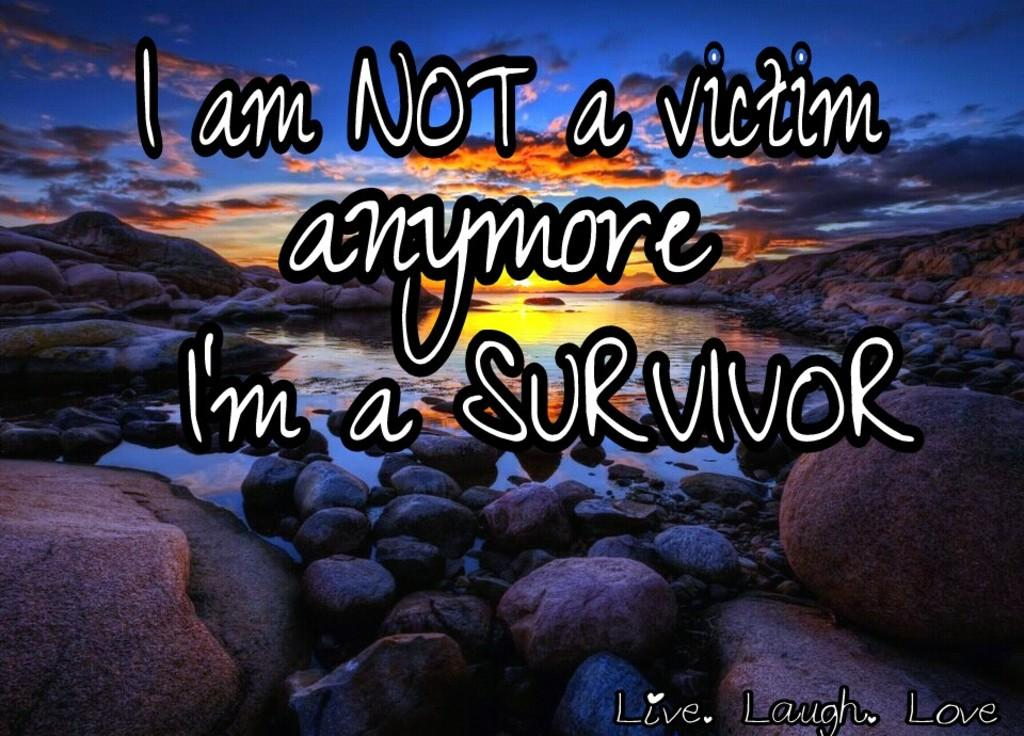<image>
Give a short and clear explanation of the subsequent image. An inspirational message about survival is on a photo of a sunset. 